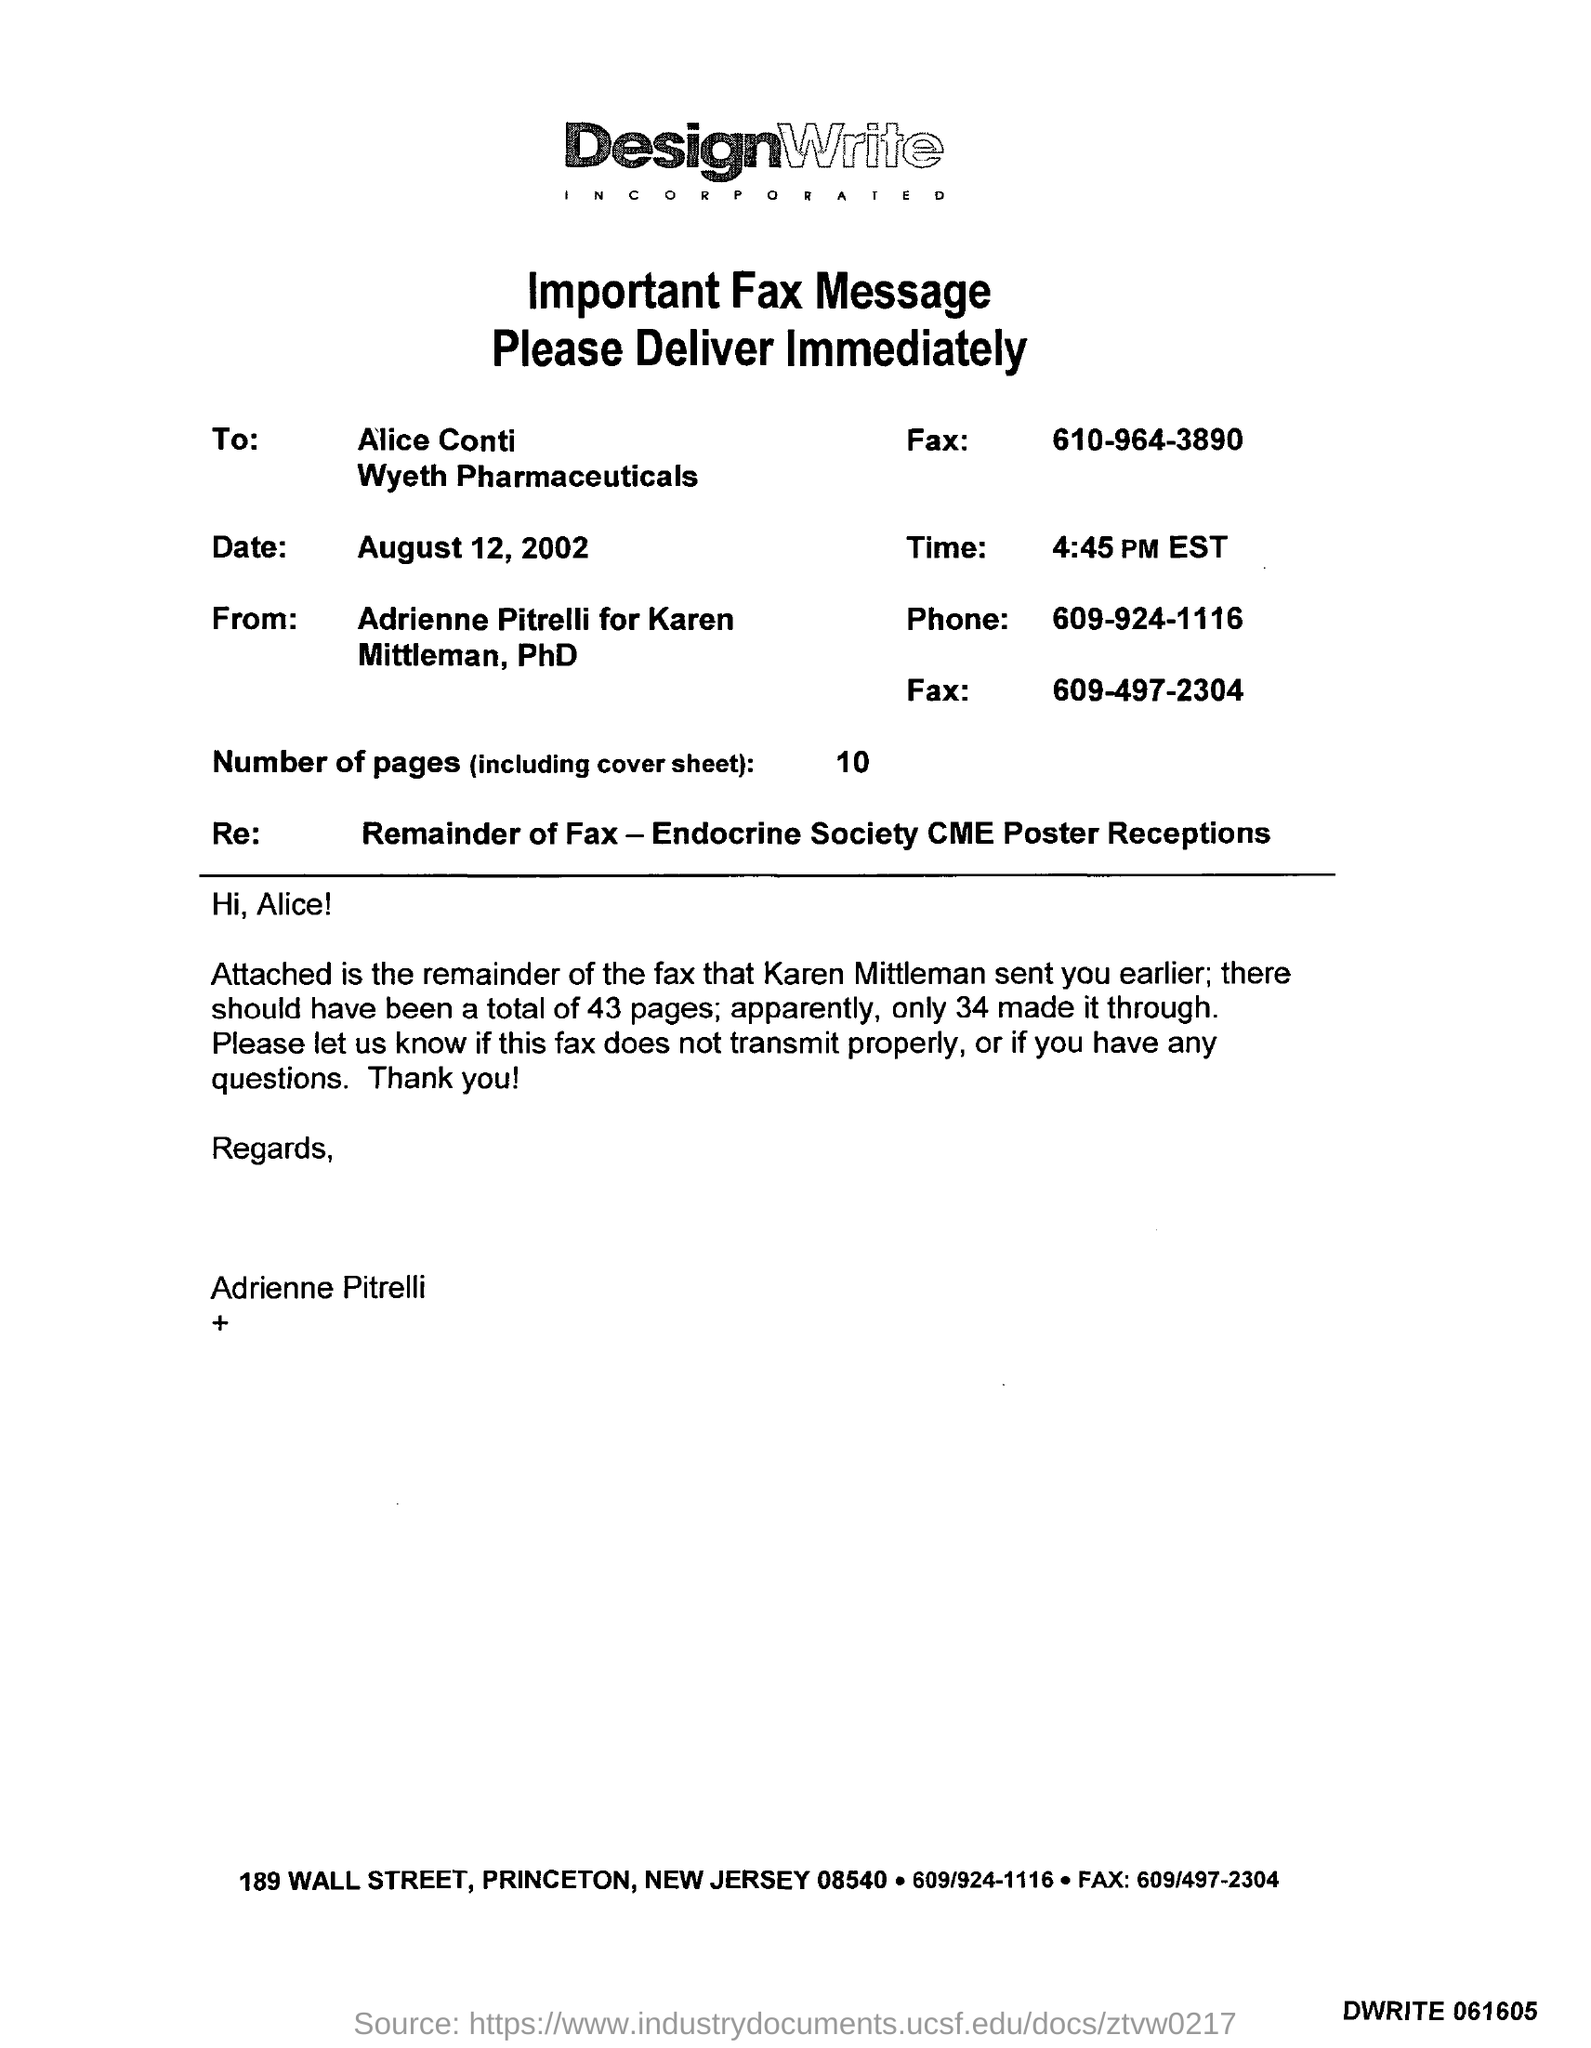What is the date?
Provide a succinct answer. AUGUST 12, 2002. What is the time?
Your response must be concise. 4:45 PM EST. What is the number of pages?
Offer a very short reply. 10. What is the phone number?
Give a very brief answer. 609-924-1116. 